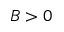<formula> <loc_0><loc_0><loc_500><loc_500>B > 0</formula> 